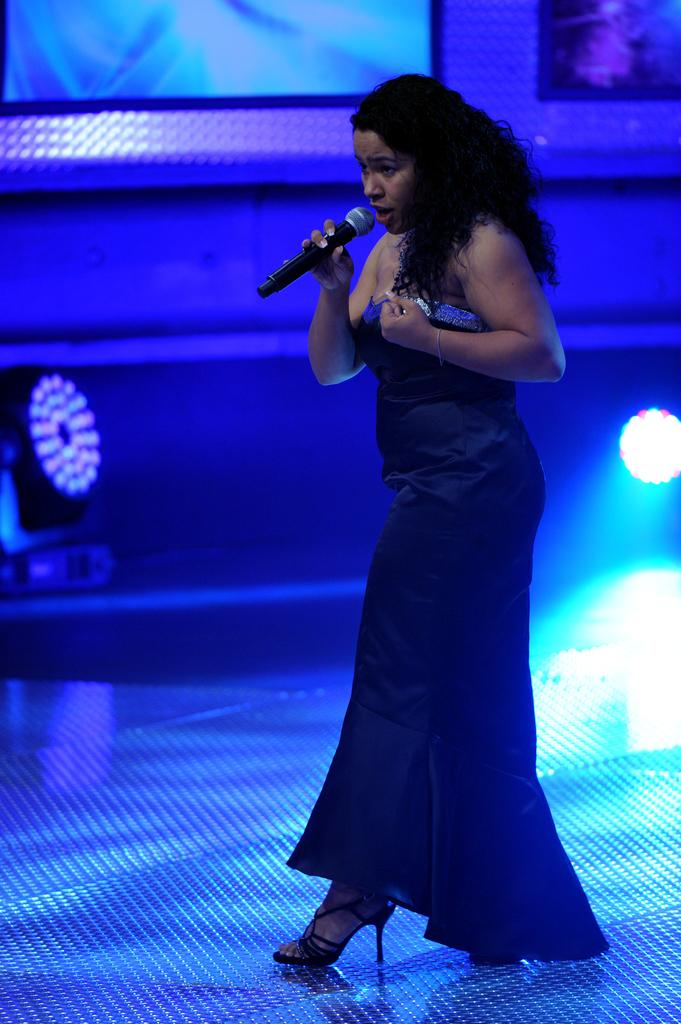Who is the main subject in the foreground of the image? There is a woman in the foreground of the image. What is the woman wearing? The woman is wearing a blue dress. Where is the woman located in the image? The woman is on a stage. What is the woman holding in her hand? The woman is holding a microphone in her hand. What can be seen in the background of the image? There is a wall and lights in the background of the image. Can you see a rod being used by the woman in the image? There is no rod visible in the image; the woman is holding a microphone. Is there a volcano erupting in the background of the image? There is no volcano present in the image; the background features a wall and lights. 